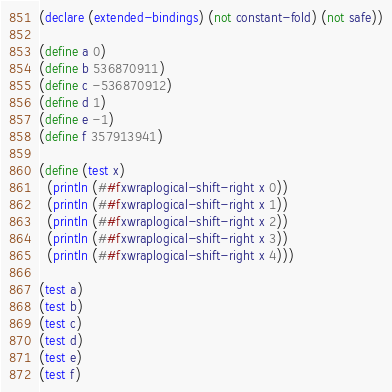Convert code to text. <code><loc_0><loc_0><loc_500><loc_500><_Scheme_>(declare (extended-bindings) (not constant-fold) (not safe))

(define a 0)
(define b 536870911)
(define c -536870912)
(define d 1)
(define e -1)
(define f 357913941)

(define (test x)
  (println (##fxwraplogical-shift-right x 0))
  (println (##fxwraplogical-shift-right x 1))
  (println (##fxwraplogical-shift-right x 2))
  (println (##fxwraplogical-shift-right x 3))
  (println (##fxwraplogical-shift-right x 4)))

(test a)
(test b)
(test c)
(test d)
(test e)
(test f)
</code> 